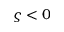Convert formula to latex. <formula><loc_0><loc_0><loc_500><loc_500>\varsigma < 0</formula> 